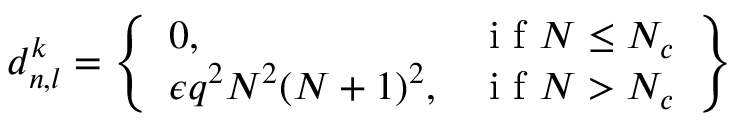Convert formula to latex. <formula><loc_0><loc_0><loc_500><loc_500>d _ { n , l } ^ { k } = \left \{ \begin{array} { l r } { 0 , } & { i f N \leq N _ { c } } \\ { \epsilon q ^ { 2 } N ^ { 2 } ( N + 1 ) ^ { 2 } , } & { i f N > N _ { c } } \end{array} \right \}</formula> 